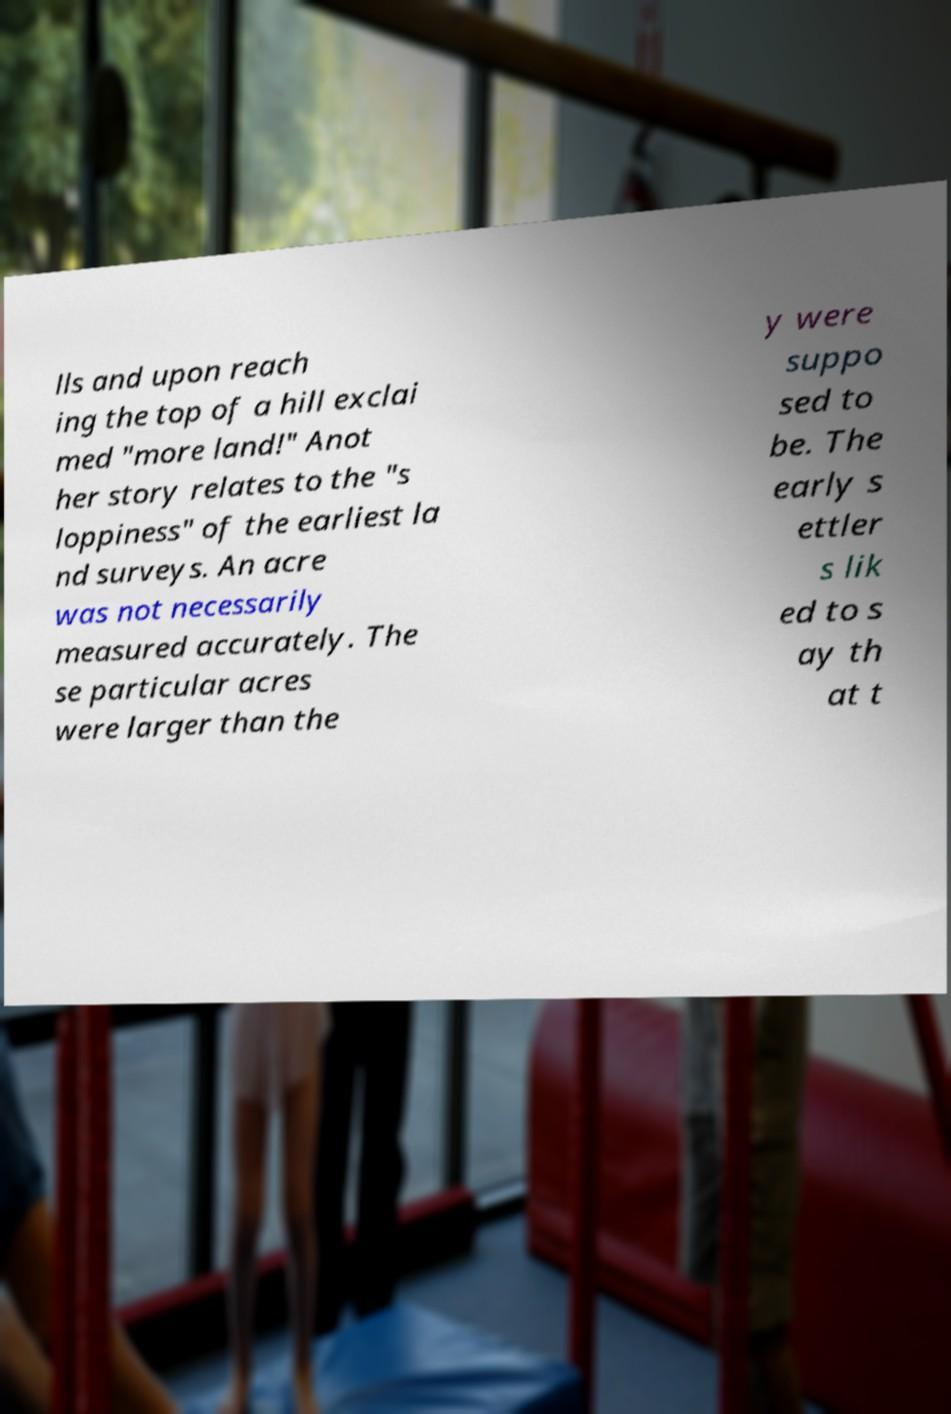Could you extract and type out the text from this image? lls and upon reach ing the top of a hill exclai med "more land!" Anot her story relates to the "s loppiness" of the earliest la nd surveys. An acre was not necessarily measured accurately. The se particular acres were larger than the y were suppo sed to be. The early s ettler s lik ed to s ay th at t 